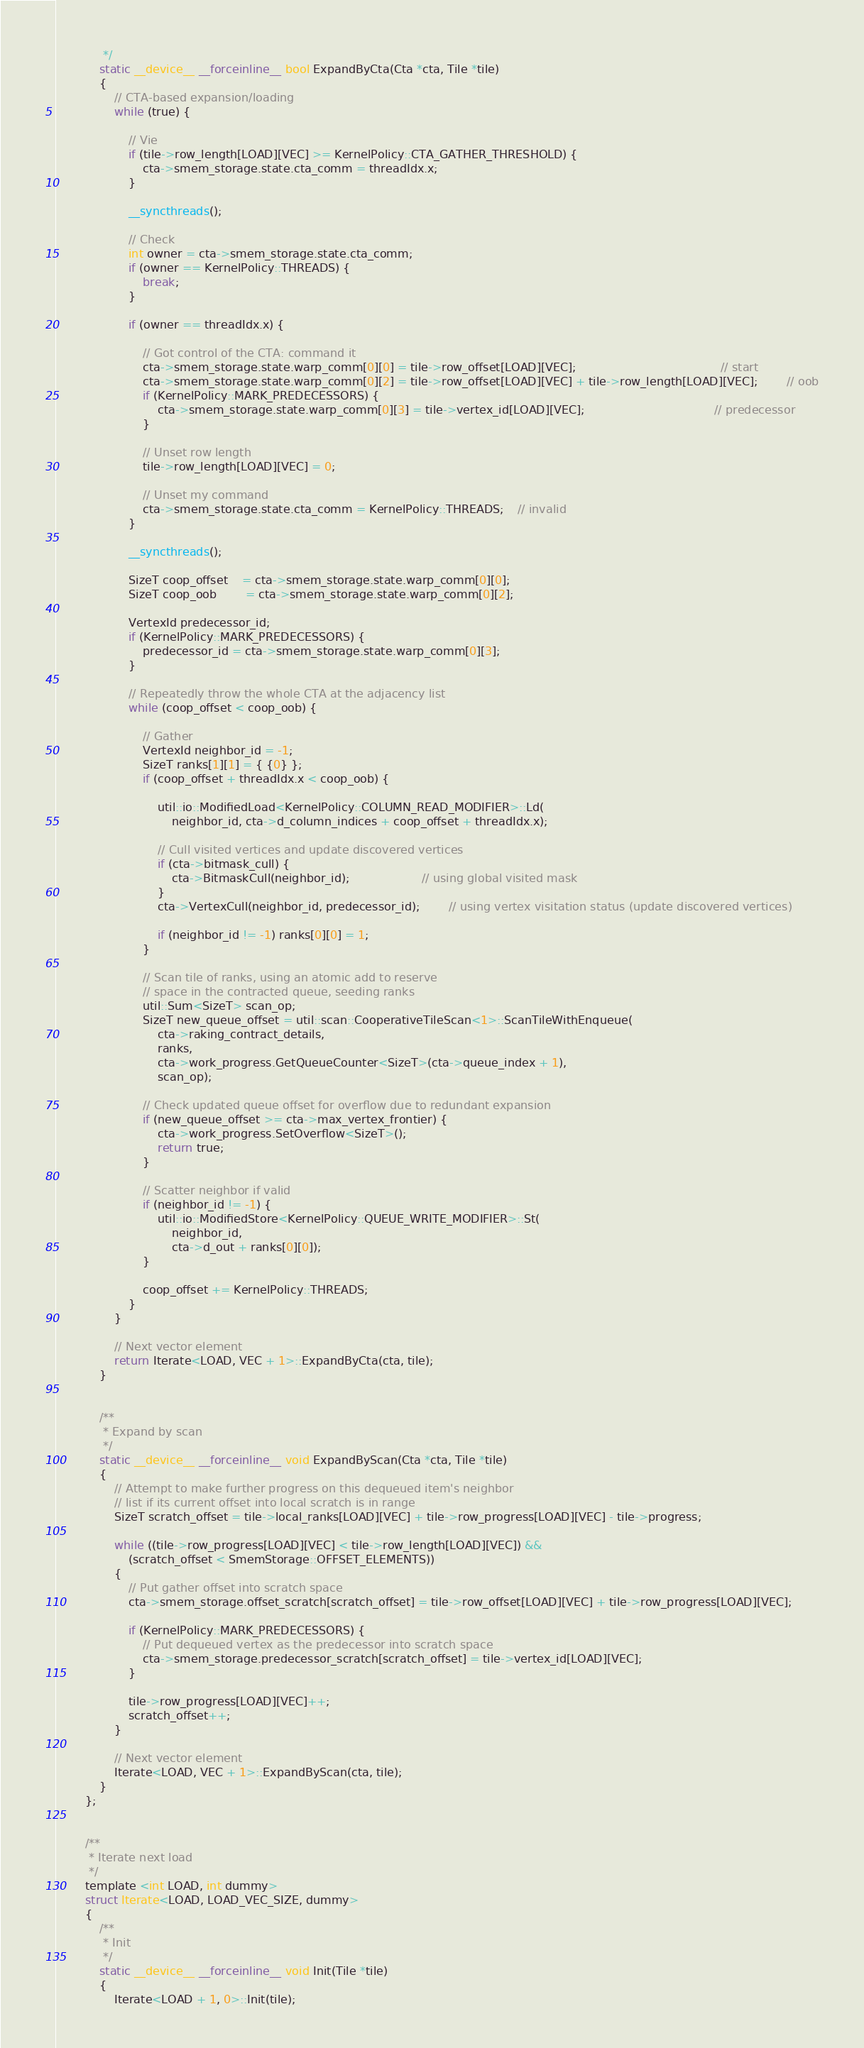Convert code to text. <code><loc_0><loc_0><loc_500><loc_500><_Cuda_>			 */
			static __device__ __forceinline__ bool ExpandByCta(Cta *cta, Tile *tile)
			{
				// CTA-based expansion/loading
				while (true) {

					// Vie
					if (tile->row_length[LOAD][VEC] >= KernelPolicy::CTA_GATHER_THRESHOLD) {
						cta->smem_storage.state.cta_comm = threadIdx.x;
					}

					__syncthreads();

					// Check
					int owner = cta->smem_storage.state.cta_comm;
					if (owner == KernelPolicy::THREADS) {
						break;
					}

					if (owner == threadIdx.x) {

						// Got control of the CTA: command it
						cta->smem_storage.state.warp_comm[0][0] = tile->row_offset[LOAD][VEC];										// start
						cta->smem_storage.state.warp_comm[0][2] = tile->row_offset[LOAD][VEC] + tile->row_length[LOAD][VEC];		// oob
						if (KernelPolicy::MARK_PREDECESSORS) {
							cta->smem_storage.state.warp_comm[0][3] = tile->vertex_id[LOAD][VEC];									// predecessor
						}

						// Unset row length
						tile->row_length[LOAD][VEC] = 0;

						// Unset my command
						cta->smem_storage.state.cta_comm = KernelPolicy::THREADS;	// invalid
					}

					__syncthreads();

					SizeT coop_offset 	= cta->smem_storage.state.warp_comm[0][0];
					SizeT coop_oob 		= cta->smem_storage.state.warp_comm[0][2];

					VertexId predecessor_id;
					if (KernelPolicy::MARK_PREDECESSORS) {
						predecessor_id = cta->smem_storage.state.warp_comm[0][3];
					}

					// Repeatedly throw the whole CTA at the adjacency list
					while (coop_offset < coop_oob) {

						// Gather
						VertexId neighbor_id = -1;
						SizeT ranks[1][1] = { {0} };
						if (coop_offset + threadIdx.x < coop_oob) {

							util::io::ModifiedLoad<KernelPolicy::COLUMN_READ_MODIFIER>::Ld(
								neighbor_id, cta->d_column_indices + coop_offset + threadIdx.x);

							// Cull visited vertices and update discovered vertices
							if (cta->bitmask_cull) {
								cta->BitmaskCull(neighbor_id);					// using global visited mask
							}
							cta->VertexCull(neighbor_id, predecessor_id);		// using vertex visitation status (update discovered vertices)

							if (neighbor_id != -1) ranks[0][0] = 1;
						}

						// Scan tile of ranks, using an atomic add to reserve
						// space in the contracted queue, seeding ranks
						util::Sum<SizeT> scan_op;
						SizeT new_queue_offset = util::scan::CooperativeTileScan<1>::ScanTileWithEnqueue(
							cta->raking_contract_details,
							ranks,
							cta->work_progress.GetQueueCounter<SizeT>(cta->queue_index + 1),
							scan_op);

						// Check updated queue offset for overflow due to redundant expansion
						if (new_queue_offset >= cta->max_vertex_frontier) {
							cta->work_progress.SetOverflow<SizeT>();
							return true;
						}

						// Scatter neighbor if valid
						if (neighbor_id != -1) {
							util::io::ModifiedStore<KernelPolicy::QUEUE_WRITE_MODIFIER>::St(
								neighbor_id,
								cta->d_out + ranks[0][0]);
						}

						coop_offset += KernelPolicy::THREADS;
					}
				}

				// Next vector element
				return Iterate<LOAD, VEC + 1>::ExpandByCta(cta, tile);
			}


			/**
			 * Expand by scan
			 */
			static __device__ __forceinline__ void ExpandByScan(Cta *cta, Tile *tile)
			{
				// Attempt to make further progress on this dequeued item's neighbor
				// list if its current offset into local scratch is in range
				SizeT scratch_offset = tile->local_ranks[LOAD][VEC] + tile->row_progress[LOAD][VEC] - tile->progress;

				while ((tile->row_progress[LOAD][VEC] < tile->row_length[LOAD][VEC]) &&
					(scratch_offset < SmemStorage::OFFSET_ELEMENTS))
				{
					// Put gather offset into scratch space
					cta->smem_storage.offset_scratch[scratch_offset] = tile->row_offset[LOAD][VEC] + tile->row_progress[LOAD][VEC];

					if (KernelPolicy::MARK_PREDECESSORS) {
						// Put dequeued vertex as the predecessor into scratch space
						cta->smem_storage.predecessor_scratch[scratch_offset] = tile->vertex_id[LOAD][VEC];
					}

					tile->row_progress[LOAD][VEC]++;
					scratch_offset++;
				}

				// Next vector element
				Iterate<LOAD, VEC + 1>::ExpandByScan(cta, tile);
			}
		};


		/**
		 * Iterate next load
		 */
		template <int LOAD, int dummy>
		struct Iterate<LOAD, LOAD_VEC_SIZE, dummy>
		{
			/**
			 * Init
			 */
			static __device__ __forceinline__ void Init(Tile *tile)
			{
				Iterate<LOAD + 1, 0>::Init(tile);</code> 